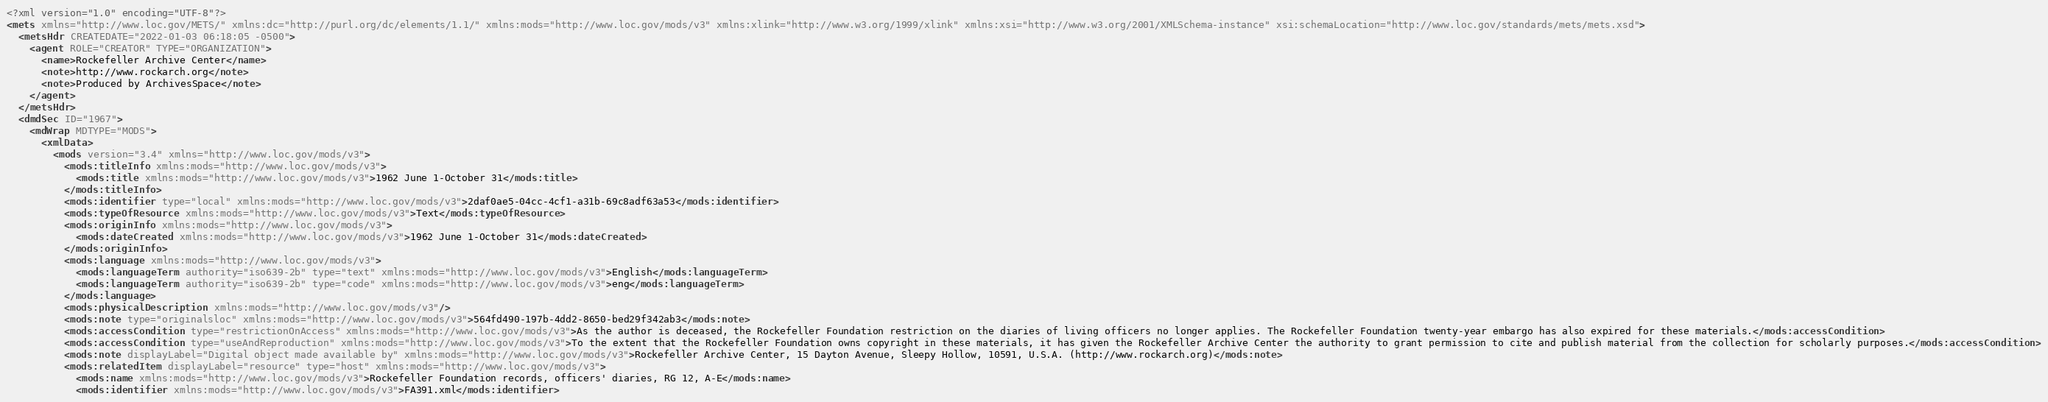Convert code to text. <code><loc_0><loc_0><loc_500><loc_500><_XML_><?xml version="1.0" encoding="UTF-8"?>
<mets xmlns="http://www.loc.gov/METS/" xmlns:dc="http://purl.org/dc/elements/1.1/" xmlns:mods="http://www.loc.gov/mods/v3" xmlns:xlink="http://www.w3.org/1999/xlink" xmlns:xsi="http://www.w3.org/2001/XMLSchema-instance" xsi:schemaLocation="http://www.loc.gov/standards/mets/mets.xsd">
  <metsHdr CREATEDATE="2022-01-03 06:18:05 -0500">
    <agent ROLE="CREATOR" TYPE="ORGANIZATION">
      <name>Rockefeller Archive Center</name>
      <note>http://www.rockarch.org</note>
      <note>Produced by ArchivesSpace</note>
    </agent>
  </metsHdr>
  <dmdSec ID="1967">
    <mdWrap MDTYPE="MODS">
      <xmlData>
        <mods version="3.4" xmlns="http://www.loc.gov/mods/v3">
          <mods:titleInfo xmlns:mods="http://www.loc.gov/mods/v3">
            <mods:title xmlns:mods="http://www.loc.gov/mods/v3">1962 June 1-October 31</mods:title>
          </mods:titleInfo>
          <mods:identifier type="local" xmlns:mods="http://www.loc.gov/mods/v3">2daf0ae5-04cc-4cf1-a31b-69c8adf63a53</mods:identifier>
          <mods:typeOfResource xmlns:mods="http://www.loc.gov/mods/v3">Text</mods:typeOfResource>
          <mods:originInfo xmlns:mods="http://www.loc.gov/mods/v3">
            <mods:dateCreated xmlns:mods="http://www.loc.gov/mods/v3">1962 June 1-October 31</mods:dateCreated>
          </mods:originInfo>
          <mods:language xmlns:mods="http://www.loc.gov/mods/v3">
            <mods:languageTerm authority="iso639-2b" type="text" xmlns:mods="http://www.loc.gov/mods/v3">English</mods:languageTerm>
            <mods:languageTerm authority="iso639-2b" type="code" xmlns:mods="http://www.loc.gov/mods/v3">eng</mods:languageTerm>
          </mods:language>
          <mods:physicalDescription xmlns:mods="http://www.loc.gov/mods/v3"/>
          <mods:note type="originalsloc" xmlns:mods="http://www.loc.gov/mods/v3">564fd490-197b-4dd2-8650-bed29f342ab3</mods:note>
          <mods:accessCondition type="restrictionOnAccess" xmlns:mods="http://www.loc.gov/mods/v3">As the author is deceased, the Rockefeller Foundation restriction on the diaries of living officers no longer applies. The Rockefeller Foundation twenty-year embargo has also expired for these materials.</mods:accessCondition>
          <mods:accessCondition type="useAndReproduction" xmlns:mods="http://www.loc.gov/mods/v3">To the extent that the Rockefeller Foundation owns copyright in these materials, it has given the Rockefeller Archive Center the authority to grant permission to cite and publish material from the collection for scholarly purposes.</mods:accessCondition>
          <mods:note displayLabel="Digital object made available by" xmlns:mods="http://www.loc.gov/mods/v3">Rockefeller Archive Center, 15 Dayton Avenue, Sleepy Hollow, 10591, U.S.A. (http://www.rockarch.org)</mods:note>
          <mods:relatedItem displayLabel="resource" type="host" xmlns:mods="http://www.loc.gov/mods/v3">
            <mods:name xmlns:mods="http://www.loc.gov/mods/v3">Rockefeller Foundation records, officers' diaries, RG 12, A-E</mods:name>
            <mods:identifier xmlns:mods="http://www.loc.gov/mods/v3">FA391.xml</mods:identifier></code> 